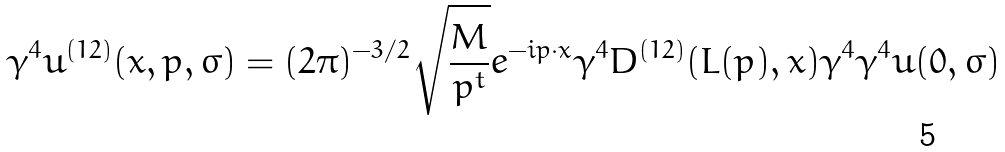Convert formula to latex. <formula><loc_0><loc_0><loc_500><loc_500>\gamma ^ { 4 } u ^ { ( 1 2 ) } ( x , { p } , \sigma ) = ( 2 \pi ) ^ { - 3 / 2 } \sqrt { \frac { M } { p ^ { t } } } e ^ { - i p \cdot x } \gamma ^ { 4 } D ^ { ( 1 2 ) } ( L ( p ) , x ) \gamma ^ { 4 } \gamma ^ { 4 } u ( 0 , \sigma )</formula> 